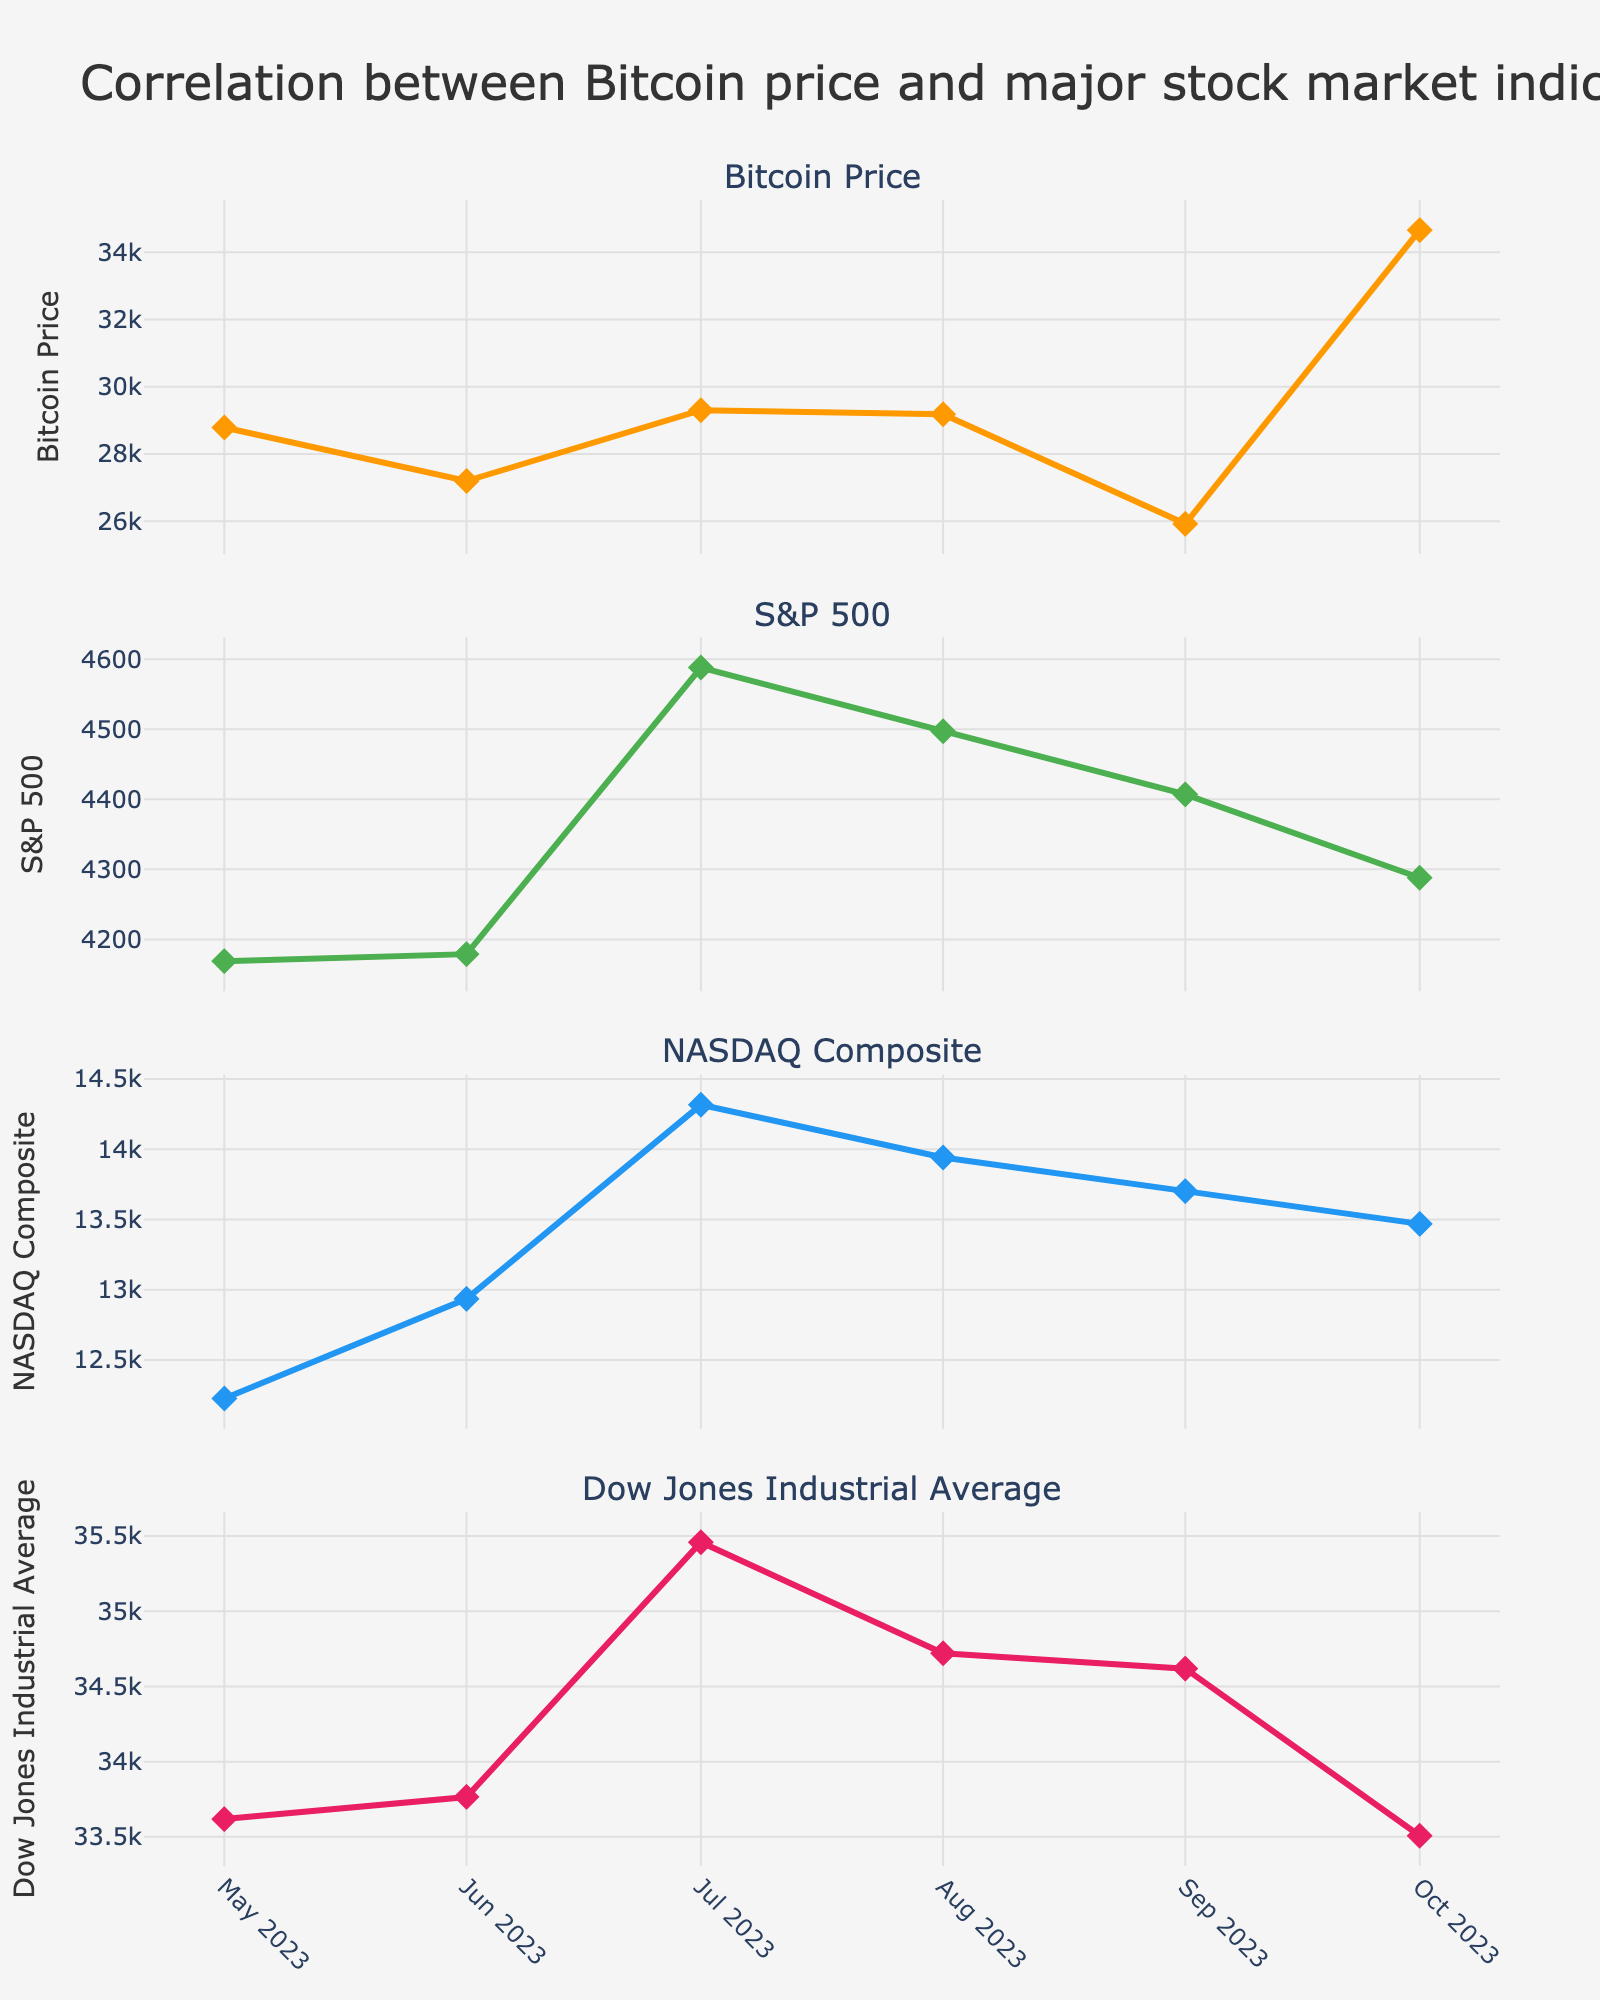What's the title of the figure? The title of the figure is located at the top of the plot. It reads "Correlation between Bitcoin price and major stock market indices".
Answer: Correlation between Bitcoin price and major stock market indices How many subplots are present in the figure? The figure contains horizontal subplots for each index. Counting each subplot from top to bottom, there are a total of four subplots.
Answer: Four Which subplot shows the Bitcoin price trend? The subplots are ordered from top to bottom based on their titles. The first subplot from the top has the title "Bitcoin Price".
Answer: The first subplot What is the highest Bitcoin price shown in the figure and when was it observed? The highest Bitcoin price can be seen as a peak in the Bitcoin Price subplot. The highest value is around 34654, which is observed in October 2023.
Answer: 34654 in October 2023 Which stock index showed the most increase from May 2023 to October 2023? By examining the trends, compare the starting and ending points of each stock index. The NASDAQ Composite starts at around 12226 and increases to around 13469, showing the largest difference compared to others.
Answer: NASDAQ Composite What was the trend of the Dow Jones Industrial Average from July 2023 to October 2023? In the Dow Jones subplot, look at the data points for July, August, September, and October. The values start high in July, dip slightly in August and September, and further decline in October.
Answer: Downward trend Which two indices have the closest values in October 2023? Check the values of all indices in October 2023 by looking at the markers. The S&P 500 and NASDAQ Composite have values of around 4288 and 13469 respectively, which are relatively closer compared to others.
Answer: S&P 500 and NASDAQ Composite Is there any index that remained relatively stable over the observed 6 months? By scanning each subplot for trend consistency over the observed period, it can be noticed that the S&P 500 has minor fluctuations compared to others, maintaining values around the same range.
Answer: S&P 500 Between which two months did the Bitcoin price see the greatest drop? To determine this, look at the largest vertical gap between data points in the Bitcoin Price subplot. The greatest drop is from August 2023 (29180) to September 2023 (25925).
Answer: Between August 2023 and September 2023 What can you infer about the relationship between Bitcoin prices and major indices based on the trends observed? Observing all subplots, it seems there is no direct correlation as Bitcoin prices fluctuate more dramatically and independently in comparison to the more stable stock indices trends.
Answer: No direct correlation 